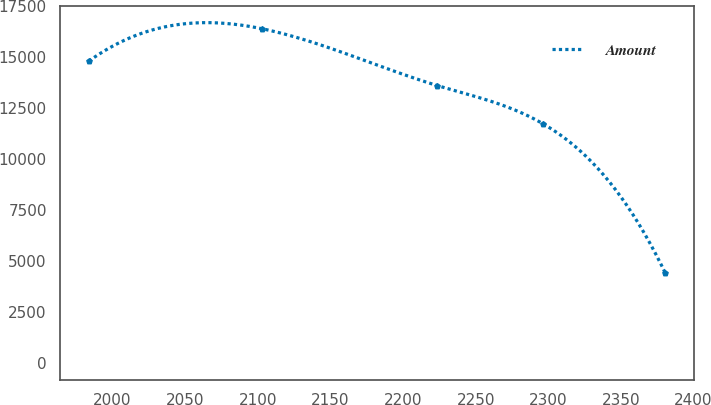Convert chart. <chart><loc_0><loc_0><loc_500><loc_500><line_chart><ecel><fcel>Amount<nl><fcel>1983.73<fcel>14817.1<nl><fcel>2103.14<fcel>16402.1<nl><fcel>2223.5<fcel>13618<nl><fcel>2296.17<fcel>11746.7<nl><fcel>2380.54<fcel>4410.85<nl></chart> 